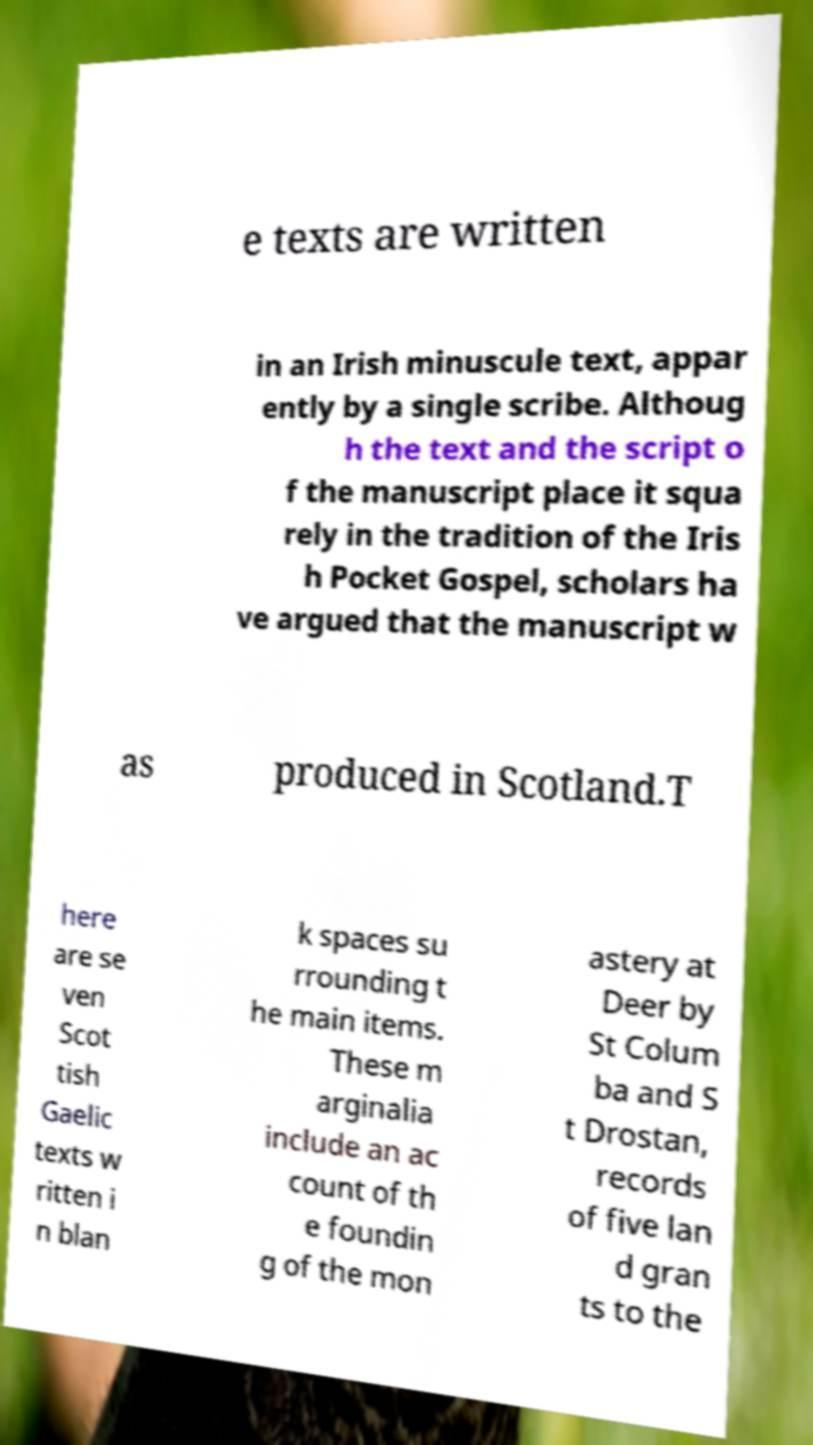Please read and relay the text visible in this image. What does it say? e texts are written in an Irish minuscule text, appar ently by a single scribe. Althoug h the text and the script o f the manuscript place it squa rely in the tradition of the Iris h Pocket Gospel, scholars ha ve argued that the manuscript w as produced in Scotland.T here are se ven Scot tish Gaelic texts w ritten i n blan k spaces su rrounding t he main items. These m arginalia include an ac count of th e foundin g of the mon astery at Deer by St Colum ba and S t Drostan, records of five lan d gran ts to the 